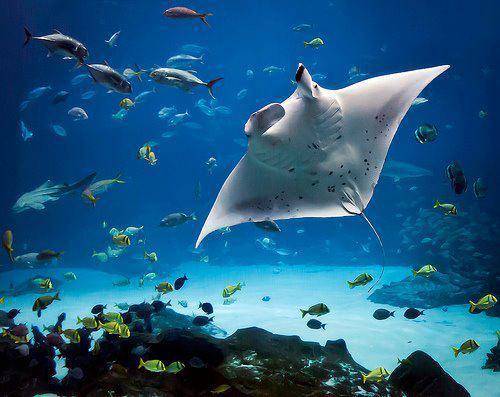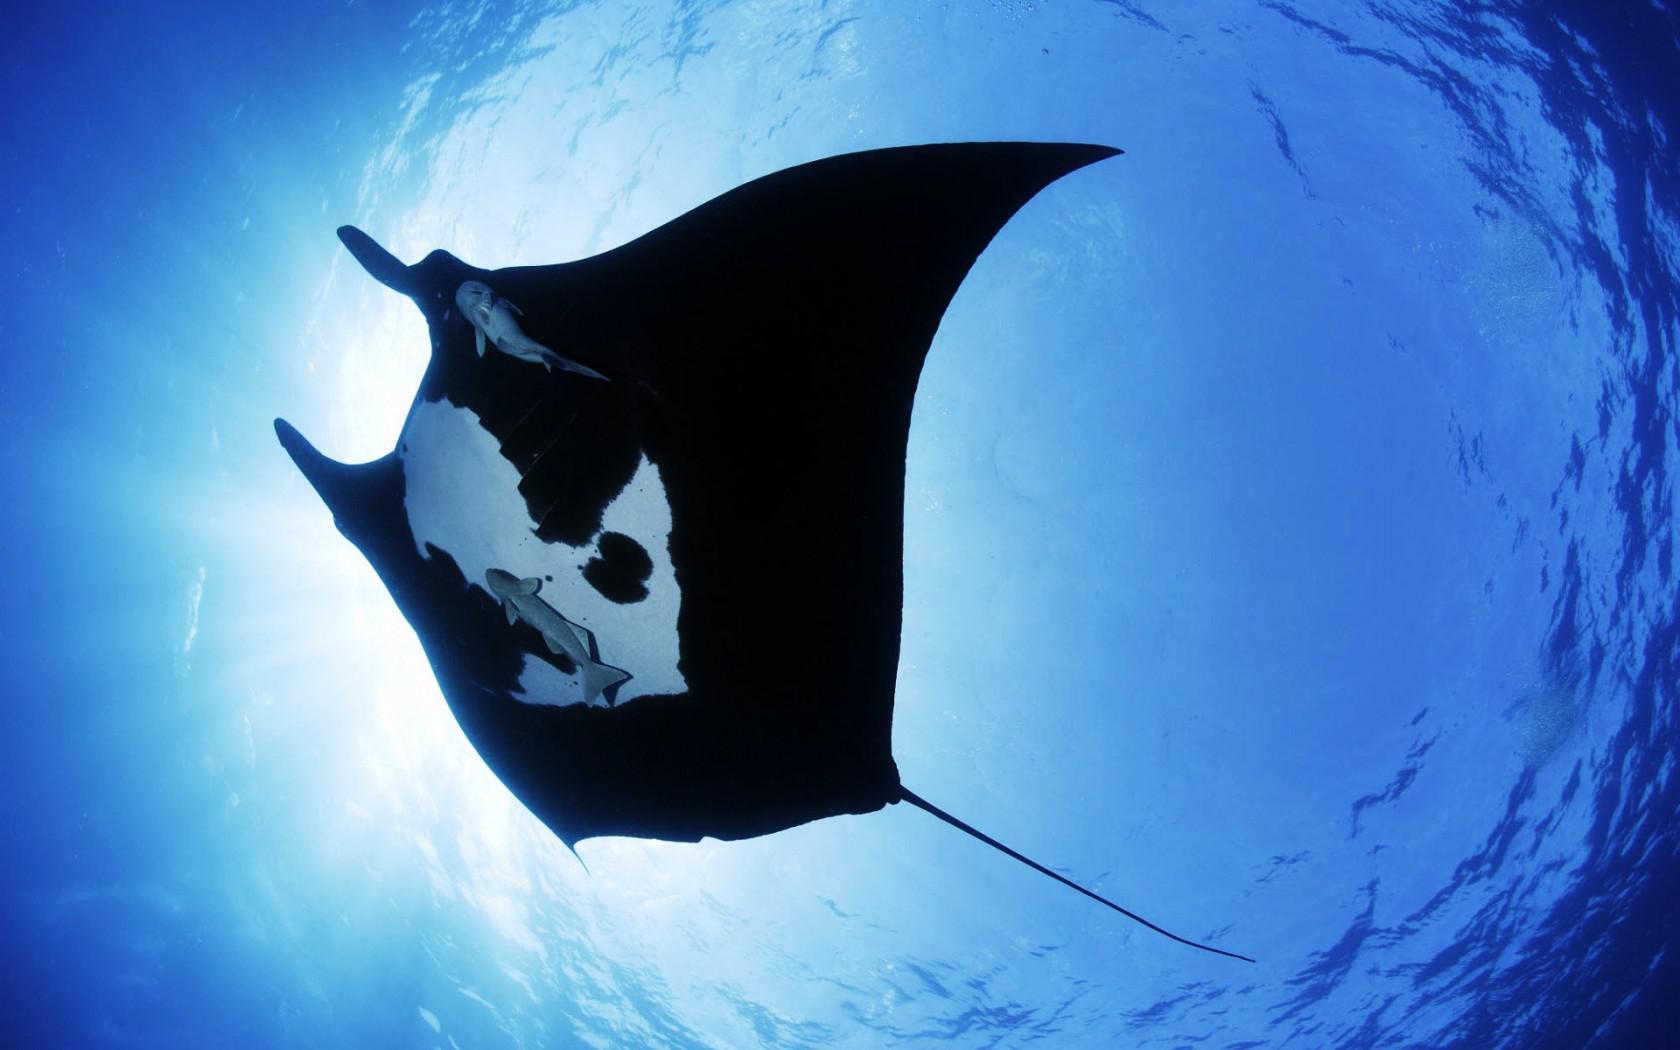The first image is the image on the left, the second image is the image on the right. Examine the images to the left and right. Is the description "The stingray on the left is black." accurate? Answer yes or no. No. The first image is the image on the left, the second image is the image on the right. Given the left and right images, does the statement "An image shows one mostly black stingray swimming toward the upper left." hold true? Answer yes or no. Yes. 